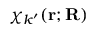Convert formula to latex. <formula><loc_0><loc_0><loc_500><loc_500>\chi _ { k ^ { \prime } } ( r ; R )</formula> 